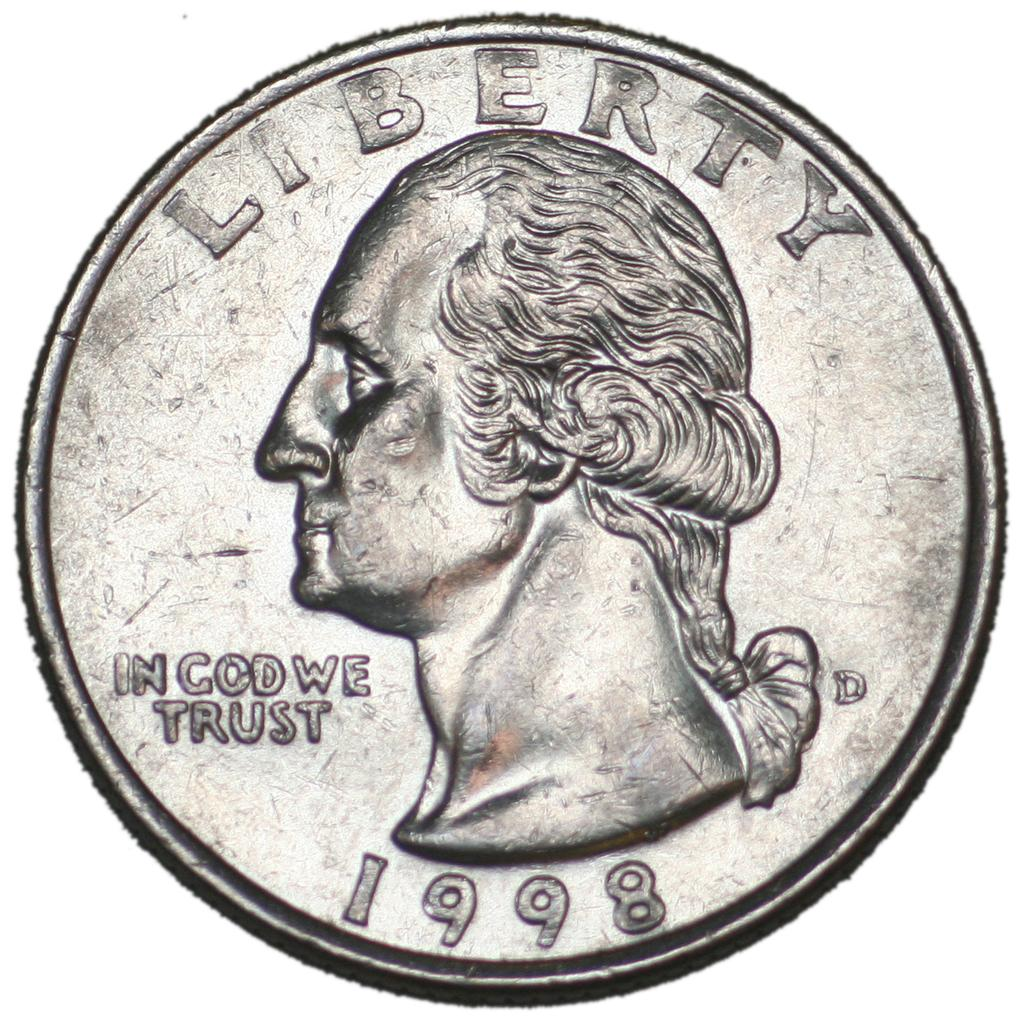Provide a one-sentence caption for the provided image. a silver liberty quarter from 1998 equals 25 cents. 